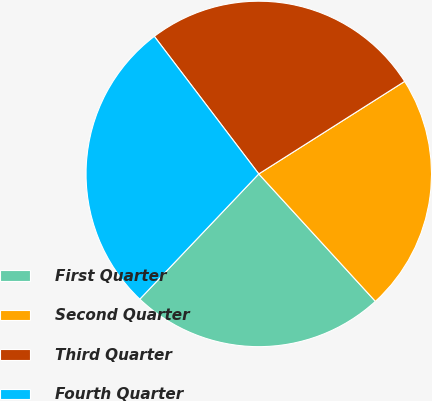Convert chart. <chart><loc_0><loc_0><loc_500><loc_500><pie_chart><fcel>First Quarter<fcel>Second Quarter<fcel>Third Quarter<fcel>Fourth Quarter<nl><fcel>23.89%<fcel>22.2%<fcel>26.34%<fcel>27.57%<nl></chart> 